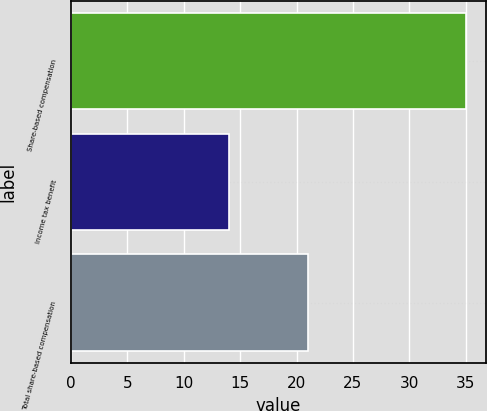Convert chart to OTSL. <chart><loc_0><loc_0><loc_500><loc_500><bar_chart><fcel>Share-based compensation<fcel>Income tax benefit<fcel>Total share-based compensation<nl><fcel>35<fcel>14<fcel>21<nl></chart> 